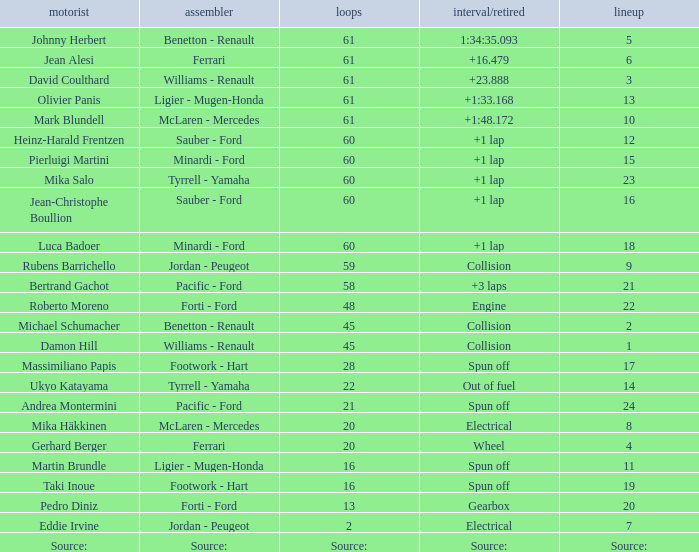Could you parse the entire table? {'header': ['motorist', 'assembler', 'loops', 'interval/retired', 'lineup'], 'rows': [['Johnny Herbert', 'Benetton - Renault', '61', '1:34:35.093', '5'], ['Jean Alesi', 'Ferrari', '61', '+16.479', '6'], ['David Coulthard', 'Williams - Renault', '61', '+23.888', '3'], ['Olivier Panis', 'Ligier - Mugen-Honda', '61', '+1:33.168', '13'], ['Mark Blundell', 'McLaren - Mercedes', '61', '+1:48.172', '10'], ['Heinz-Harald Frentzen', 'Sauber - Ford', '60', '+1 lap', '12'], ['Pierluigi Martini', 'Minardi - Ford', '60', '+1 lap', '15'], ['Mika Salo', 'Tyrrell - Yamaha', '60', '+1 lap', '23'], ['Jean-Christophe Boullion', 'Sauber - Ford', '60', '+1 lap', '16'], ['Luca Badoer', 'Minardi - Ford', '60', '+1 lap', '18'], ['Rubens Barrichello', 'Jordan - Peugeot', '59', 'Collision', '9'], ['Bertrand Gachot', 'Pacific - Ford', '58', '+3 laps', '21'], ['Roberto Moreno', 'Forti - Ford', '48', 'Engine', '22'], ['Michael Schumacher', 'Benetton - Renault', '45', 'Collision', '2'], ['Damon Hill', 'Williams - Renault', '45', 'Collision', '1'], ['Massimiliano Papis', 'Footwork - Hart', '28', 'Spun off', '17'], ['Ukyo Katayama', 'Tyrrell - Yamaha', '22', 'Out of fuel', '14'], ['Andrea Montermini', 'Pacific - Ford', '21', 'Spun off', '24'], ['Mika Häkkinen', 'McLaren - Mercedes', '20', 'Electrical', '8'], ['Gerhard Berger', 'Ferrari', '20', 'Wheel', '4'], ['Martin Brundle', 'Ligier - Mugen-Honda', '16', 'Spun off', '11'], ['Taki Inoue', 'Footwork - Hart', '16', 'Spun off', '19'], ['Pedro Diniz', 'Forti - Ford', '13', 'Gearbox', '20'], ['Eddie Irvine', 'Jordan - Peugeot', '2', 'Electrical', '7'], ['Source:', 'Source:', 'Source:', 'Source:', 'Source:']]} What grid has 2 laps? 7.0. 